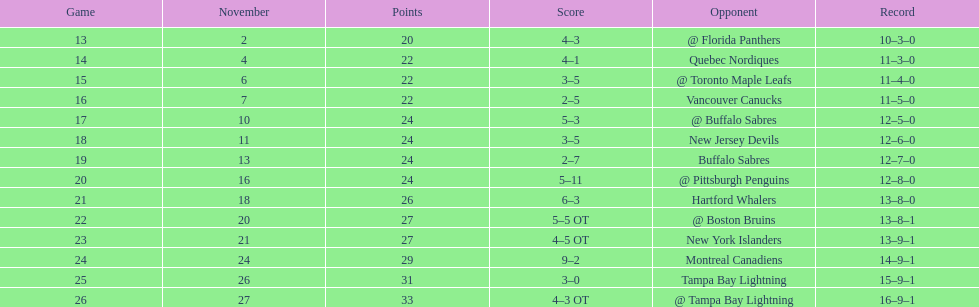What other team had the closest amount of wins? New York Islanders. 